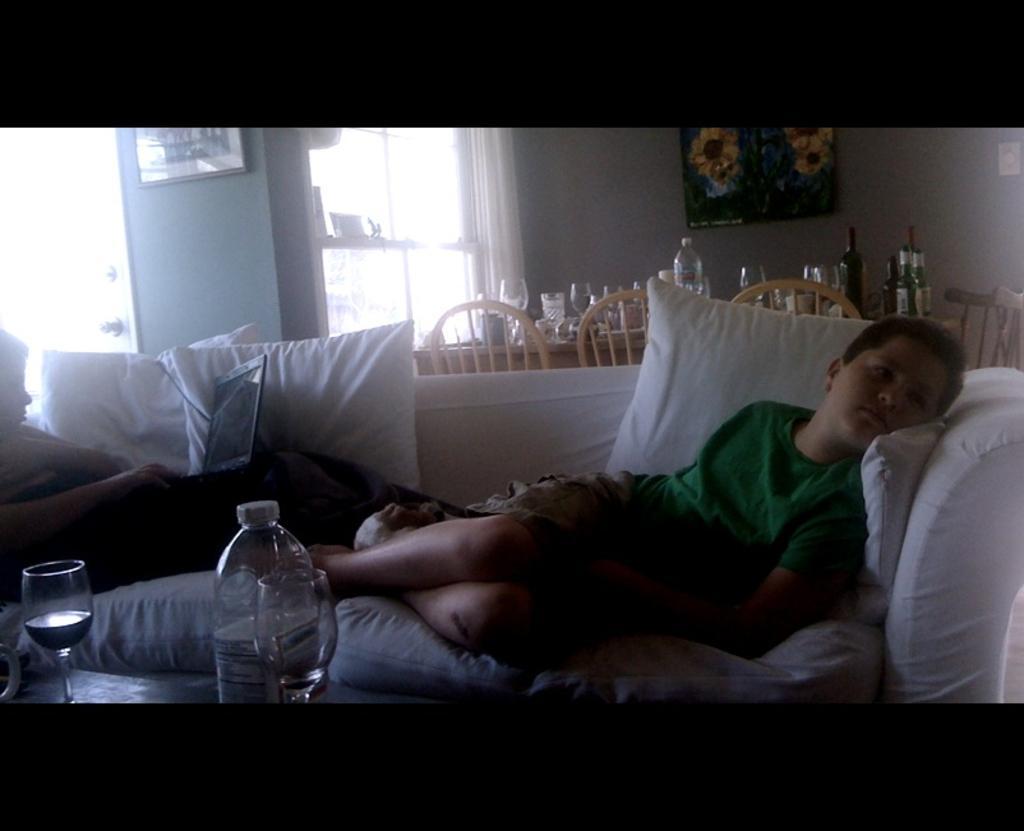Can you describe this image briefly? In this image we can see a kid wearing green color T-shirt, brown color short sleeping on couch and there is another person lying on bed who is doing some work with laptop and there are some pillows, in the foreground of the image there some glasses and bottle on table and in the background of the image there is a dining table and some chairs, there are some glasses, bottles, bowls on table and there are some paintings attached to the wall. 